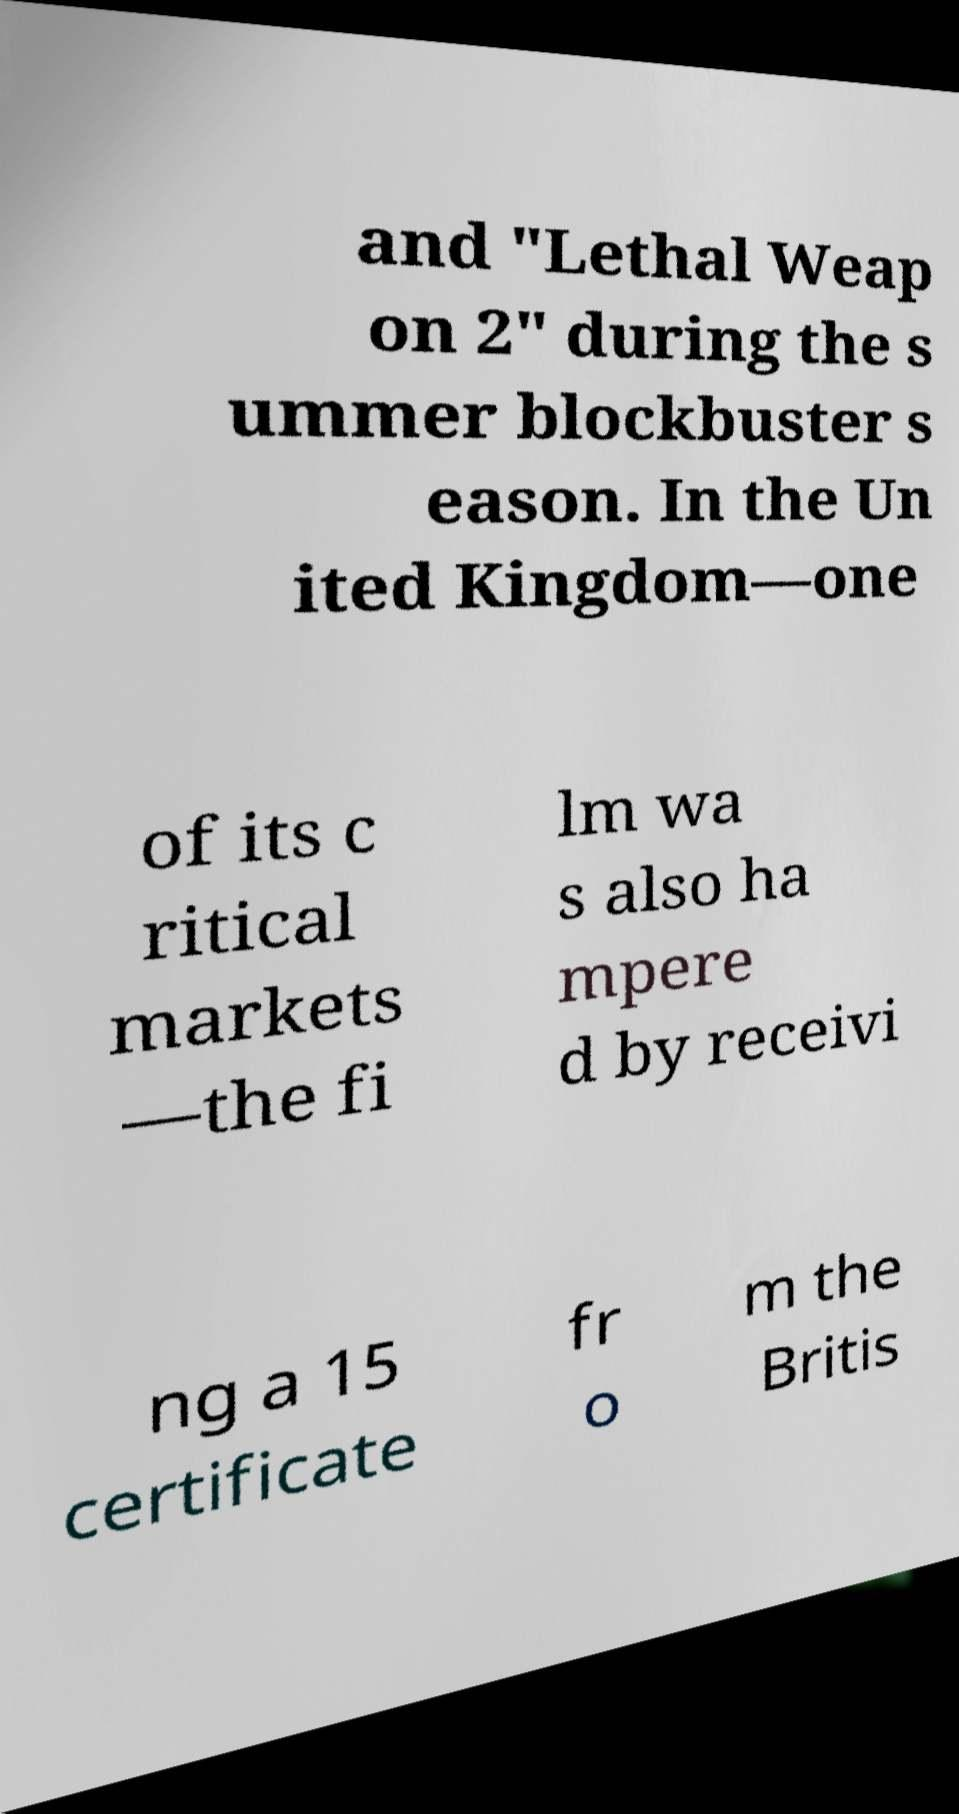For documentation purposes, I need the text within this image transcribed. Could you provide that? and "Lethal Weap on 2" during the s ummer blockbuster s eason. In the Un ited Kingdom—one of its c ritical markets —the fi lm wa s also ha mpere d by receivi ng a 15 certificate fr o m the Britis 